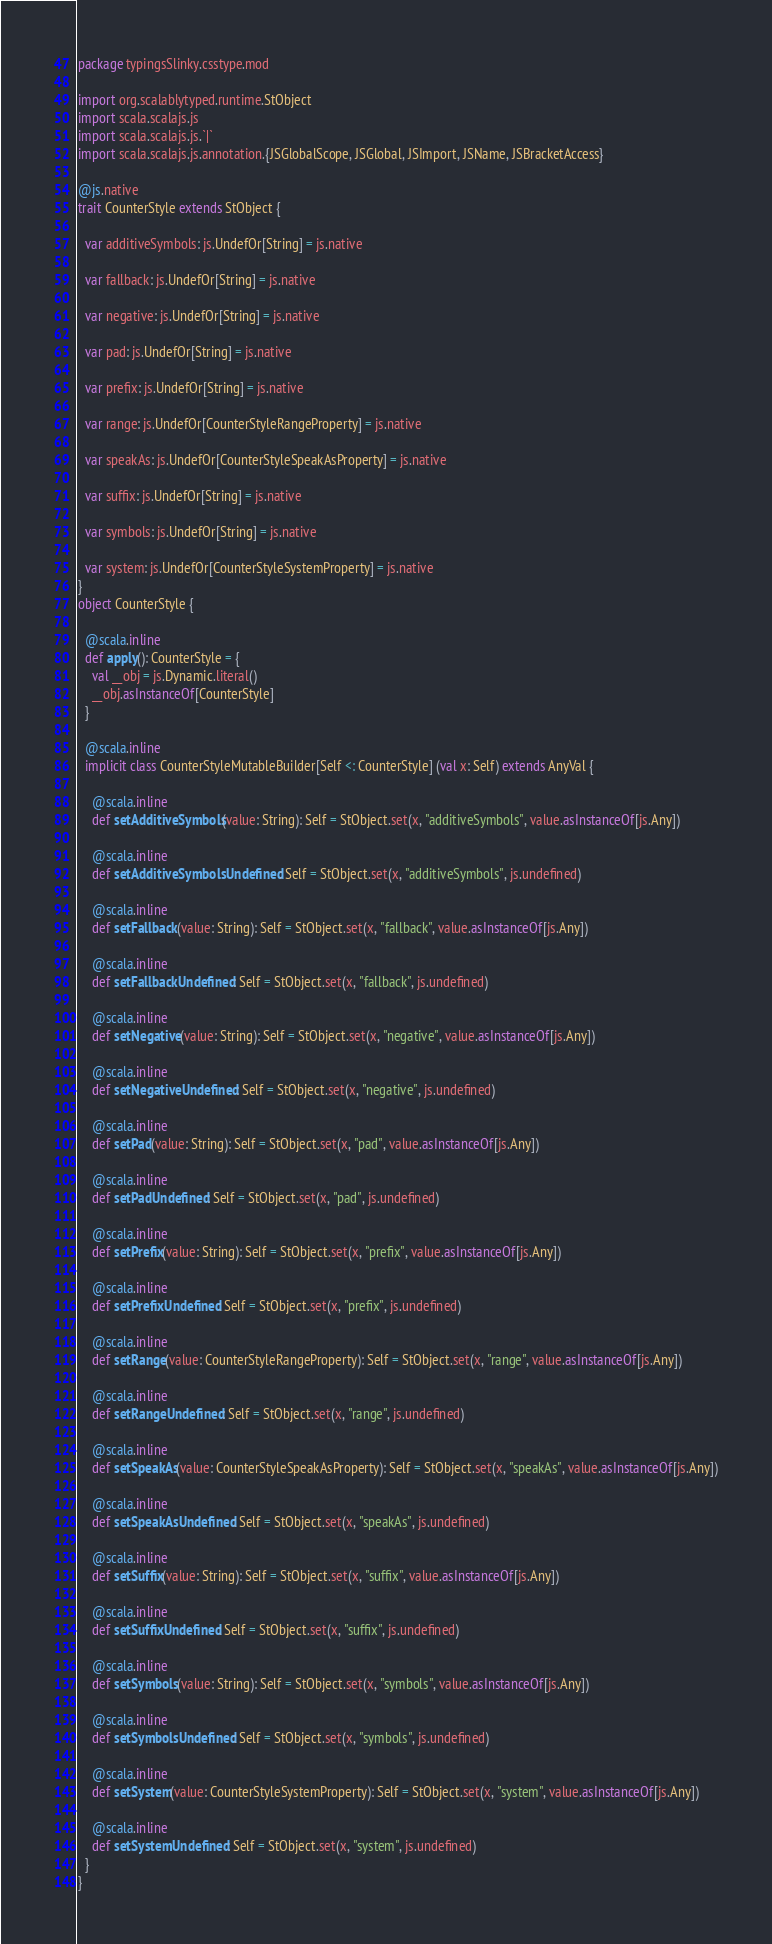<code> <loc_0><loc_0><loc_500><loc_500><_Scala_>package typingsSlinky.csstype.mod

import org.scalablytyped.runtime.StObject
import scala.scalajs.js
import scala.scalajs.js.`|`
import scala.scalajs.js.annotation.{JSGlobalScope, JSGlobal, JSImport, JSName, JSBracketAccess}

@js.native
trait CounterStyle extends StObject {
  
  var additiveSymbols: js.UndefOr[String] = js.native
  
  var fallback: js.UndefOr[String] = js.native
  
  var negative: js.UndefOr[String] = js.native
  
  var pad: js.UndefOr[String] = js.native
  
  var prefix: js.UndefOr[String] = js.native
  
  var range: js.UndefOr[CounterStyleRangeProperty] = js.native
  
  var speakAs: js.UndefOr[CounterStyleSpeakAsProperty] = js.native
  
  var suffix: js.UndefOr[String] = js.native
  
  var symbols: js.UndefOr[String] = js.native
  
  var system: js.UndefOr[CounterStyleSystemProperty] = js.native
}
object CounterStyle {
  
  @scala.inline
  def apply(): CounterStyle = {
    val __obj = js.Dynamic.literal()
    __obj.asInstanceOf[CounterStyle]
  }
  
  @scala.inline
  implicit class CounterStyleMutableBuilder[Self <: CounterStyle] (val x: Self) extends AnyVal {
    
    @scala.inline
    def setAdditiveSymbols(value: String): Self = StObject.set(x, "additiveSymbols", value.asInstanceOf[js.Any])
    
    @scala.inline
    def setAdditiveSymbolsUndefined: Self = StObject.set(x, "additiveSymbols", js.undefined)
    
    @scala.inline
    def setFallback(value: String): Self = StObject.set(x, "fallback", value.asInstanceOf[js.Any])
    
    @scala.inline
    def setFallbackUndefined: Self = StObject.set(x, "fallback", js.undefined)
    
    @scala.inline
    def setNegative(value: String): Self = StObject.set(x, "negative", value.asInstanceOf[js.Any])
    
    @scala.inline
    def setNegativeUndefined: Self = StObject.set(x, "negative", js.undefined)
    
    @scala.inline
    def setPad(value: String): Self = StObject.set(x, "pad", value.asInstanceOf[js.Any])
    
    @scala.inline
    def setPadUndefined: Self = StObject.set(x, "pad", js.undefined)
    
    @scala.inline
    def setPrefix(value: String): Self = StObject.set(x, "prefix", value.asInstanceOf[js.Any])
    
    @scala.inline
    def setPrefixUndefined: Self = StObject.set(x, "prefix", js.undefined)
    
    @scala.inline
    def setRange(value: CounterStyleRangeProperty): Self = StObject.set(x, "range", value.asInstanceOf[js.Any])
    
    @scala.inline
    def setRangeUndefined: Self = StObject.set(x, "range", js.undefined)
    
    @scala.inline
    def setSpeakAs(value: CounterStyleSpeakAsProperty): Self = StObject.set(x, "speakAs", value.asInstanceOf[js.Any])
    
    @scala.inline
    def setSpeakAsUndefined: Self = StObject.set(x, "speakAs", js.undefined)
    
    @scala.inline
    def setSuffix(value: String): Self = StObject.set(x, "suffix", value.asInstanceOf[js.Any])
    
    @scala.inline
    def setSuffixUndefined: Self = StObject.set(x, "suffix", js.undefined)
    
    @scala.inline
    def setSymbols(value: String): Self = StObject.set(x, "symbols", value.asInstanceOf[js.Any])
    
    @scala.inline
    def setSymbolsUndefined: Self = StObject.set(x, "symbols", js.undefined)
    
    @scala.inline
    def setSystem(value: CounterStyleSystemProperty): Self = StObject.set(x, "system", value.asInstanceOf[js.Any])
    
    @scala.inline
    def setSystemUndefined: Self = StObject.set(x, "system", js.undefined)
  }
}
</code> 